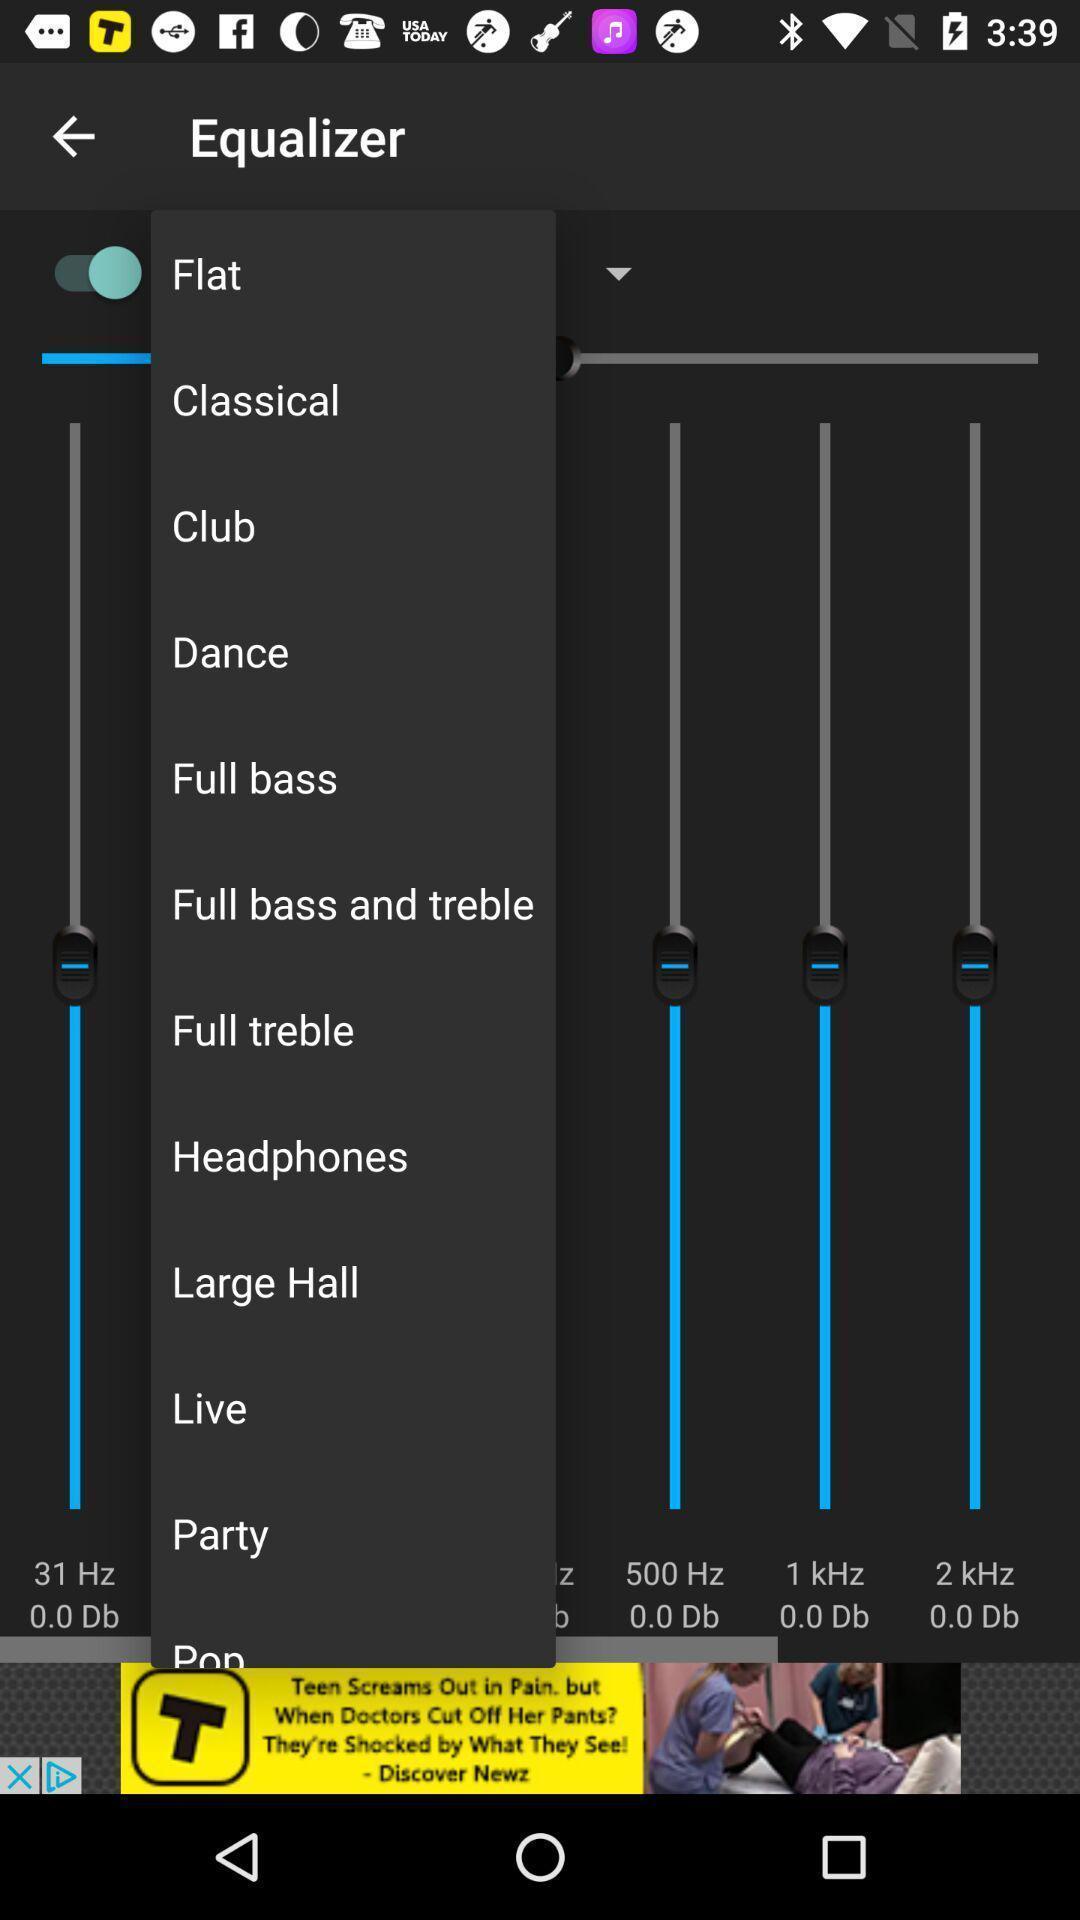Summarize the information in this screenshot. Screen showing equalizer option. 